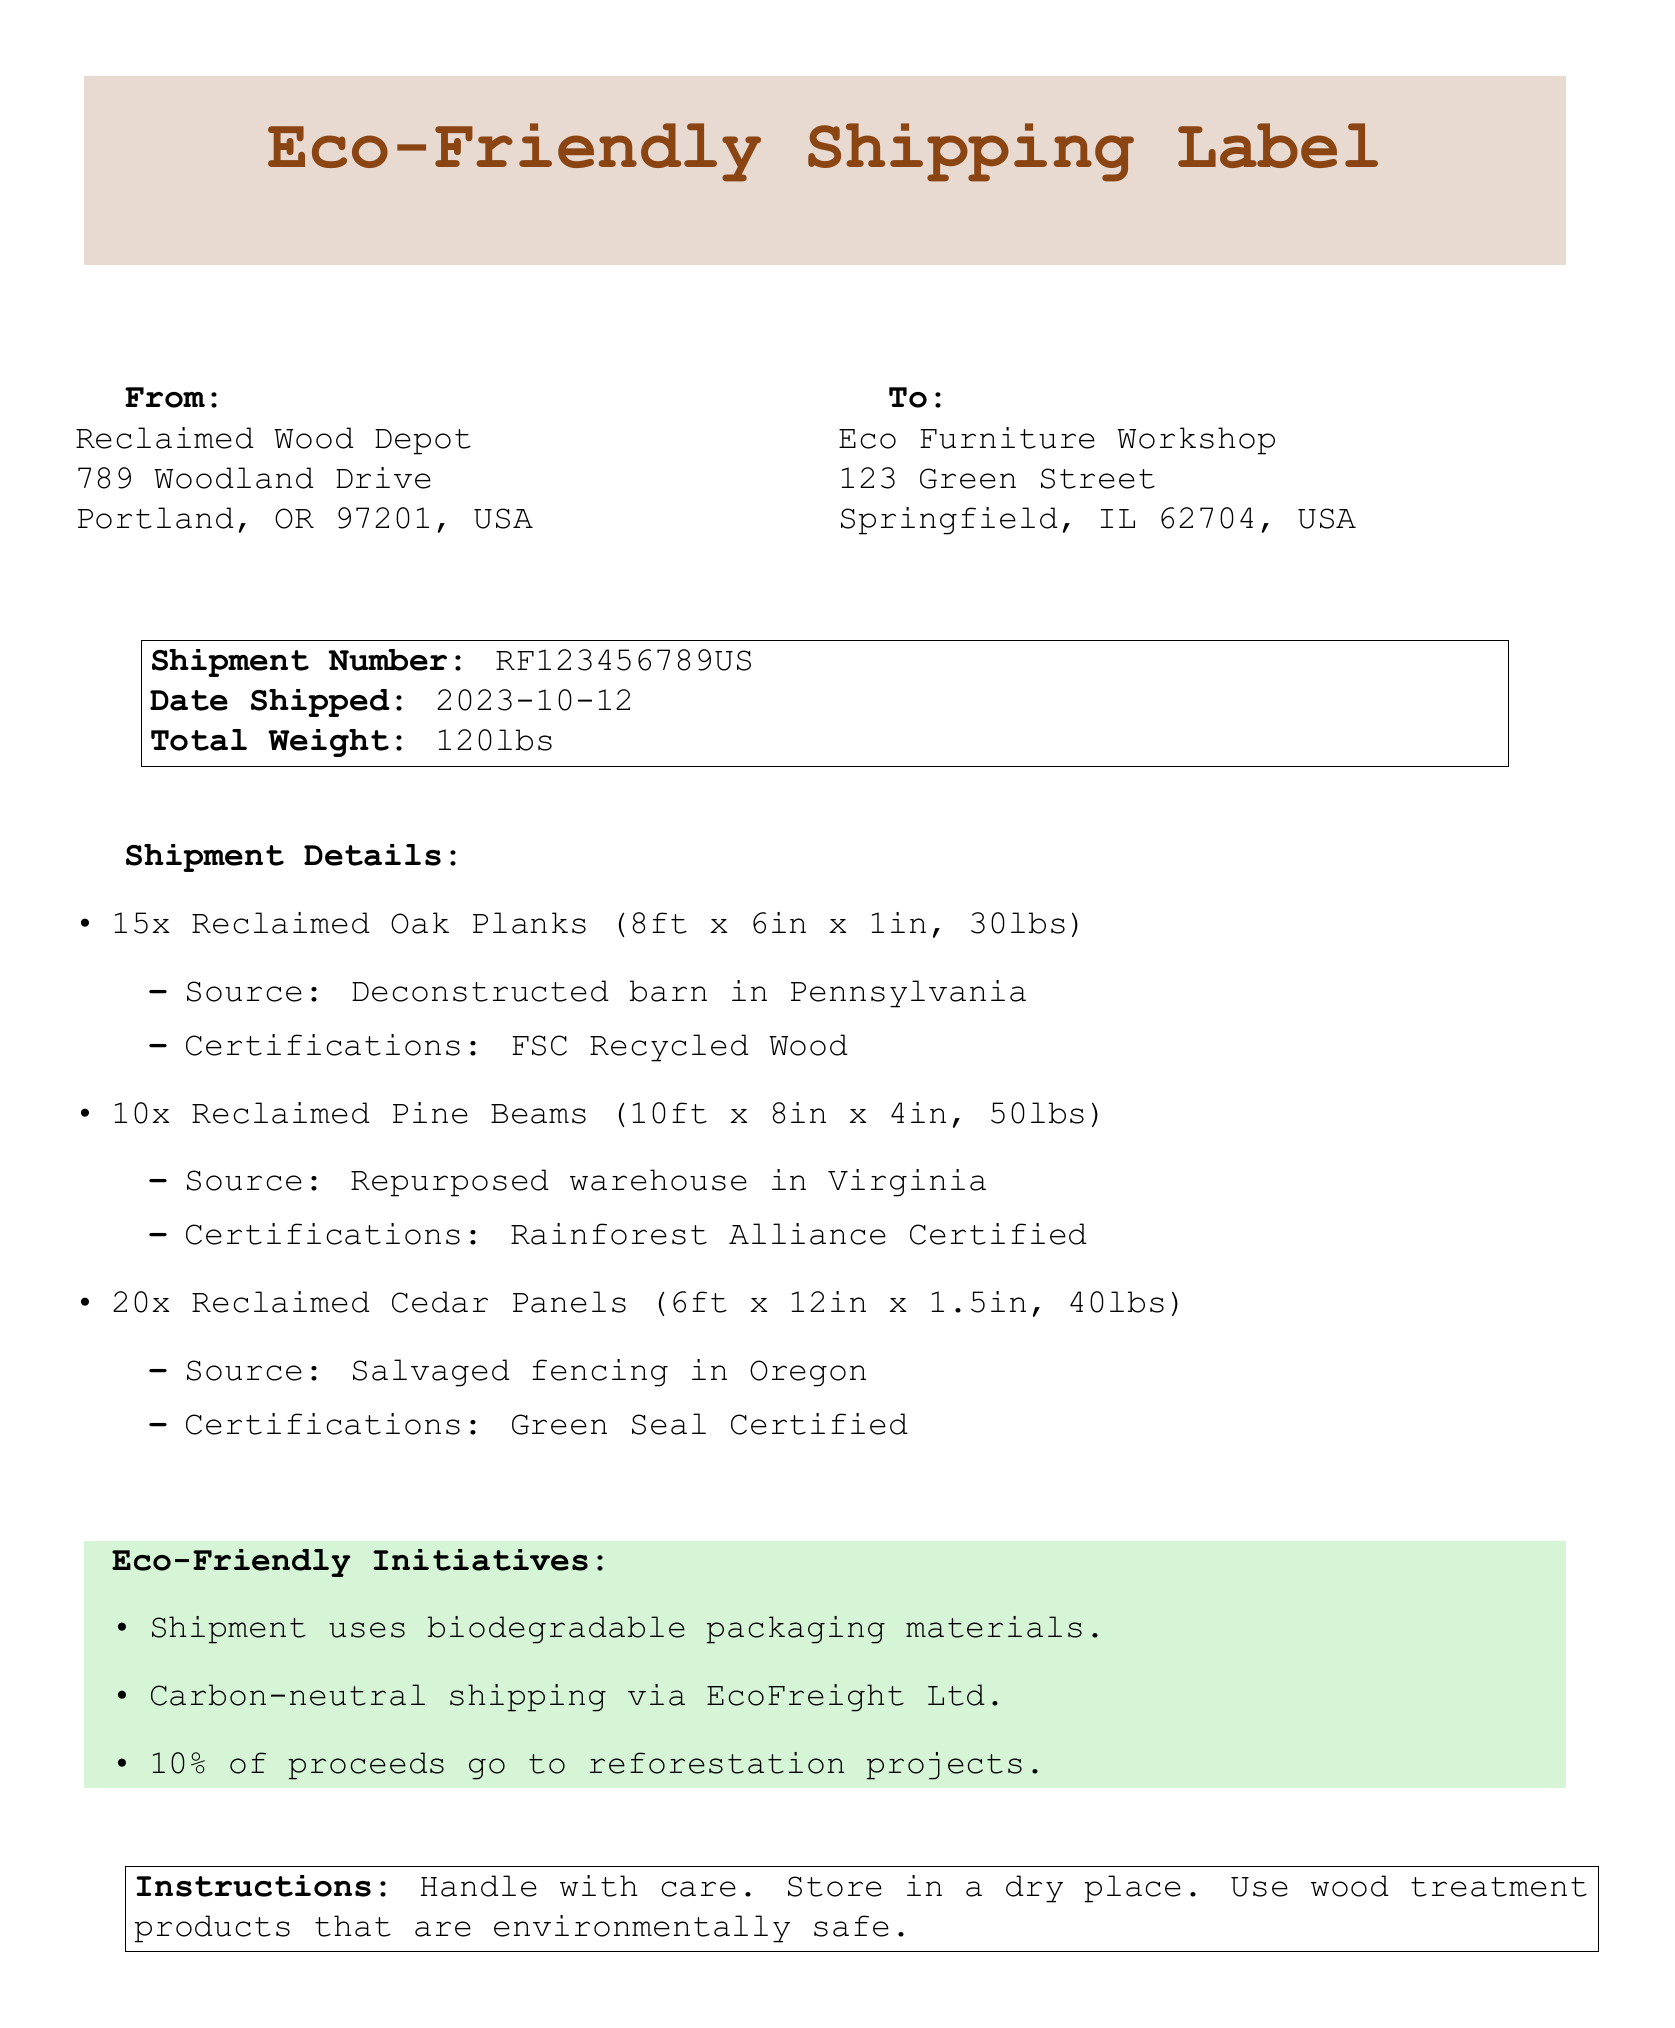What is the shipment number? The shipment number is displayed prominently in the document to identify the shipment.
Answer: RF123456789US What is the total weight of the shipment? The total weight is indicated clearly in the shipment details section of the document.
Answer: 120lbs How many Reclaimed Oak Planks are included? The number of Reclaimed Oak Planks is listed in the shipment details.
Answer: 15 Where did the Reclaimed Pine Beams come from? The source of the Reclaimed Pine Beams is provided in the itemized list of the shipment details.
Answer: Repurposed warehouse in Virginia What percentage of proceeds go to reforestation projects? The eco-friendly initiatives section mentions the specific percentage of proceeds for environmental causes.
Answer: 10% What type of shipping is used for this shipment? The document specifies the shipping method used to reduce environmental impact.
Answer: Carbon-neutral shipping What eco-certification does the Reclaimed Oak Planks have? The certifications for the Reclaimed Oak Planks are noted in the itemized details.
Answer: FSC Recycled Wood What instructions are given for handling the shipment? The instructions provided in the document focus on care for the shipment.
Answer: Handle with care What is the date shipped? The shipment date is listed in the shipment details section.
Answer: 2023-10-12 